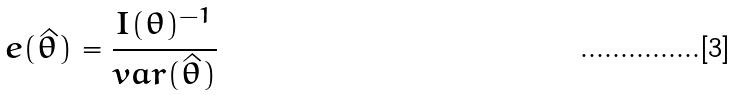Convert formula to latex. <formula><loc_0><loc_0><loc_500><loc_500>e ( \hat { \theta } ) = \frac { I ( \theta ) ^ { - 1 } } { v a r ( \hat { \theta } ) }</formula> 